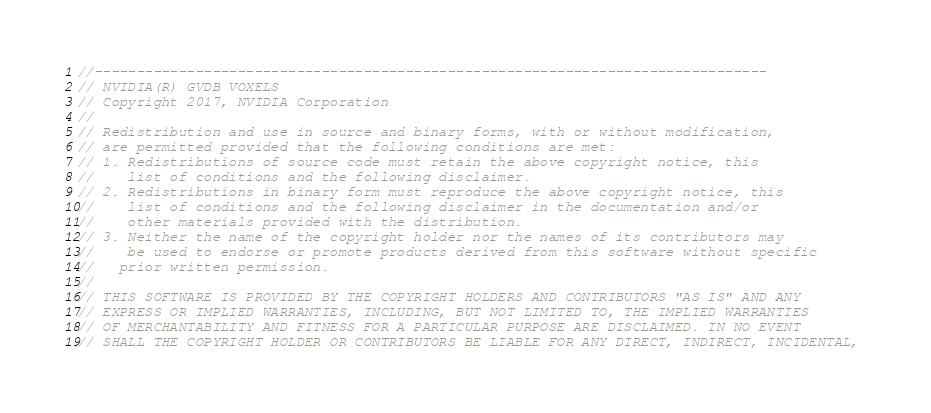<code> <loc_0><loc_0><loc_500><loc_500><_Cuda_>
//--------------------------------------------------------------------------------
// NVIDIA(R) GVDB VOXELS
// Copyright 2017, NVIDIA Corporation
//
// Redistribution and use in source and binary forms, with or without modification, 
// are permitted provided that the following conditions are met:
// 1. Redistributions of source code must retain the above copyright notice, this 
//    list of conditions and the following disclaimer.
// 2. Redistributions in binary form must reproduce the above copyright notice, this 
//    list of conditions and the following disclaimer in the documentation and/or 
//    other materials provided with the distribution.
// 3. Neither the name of the copyright holder nor the names of its contributors may 
//    be used to endorse or promote products derived from this software without specific 
//   prior written permission.
// 
// THIS SOFTWARE IS PROVIDED BY THE COPYRIGHT HOLDERS AND CONTRIBUTORS "AS IS" AND ANY 
// EXPRESS OR IMPLIED WARRANTIES, INCLUDING, BUT NOT LIMITED TO, THE IMPLIED WARRANTIES 
// OF MERCHANTABILITY AND FITNESS FOR A PARTICULAR PURPOSE ARE DISCLAIMED. IN NO EVENT 
// SHALL THE COPYRIGHT HOLDER OR CONTRIBUTORS BE LIABLE FOR ANY DIRECT, INDIRECT, INCIDENTAL, </code> 